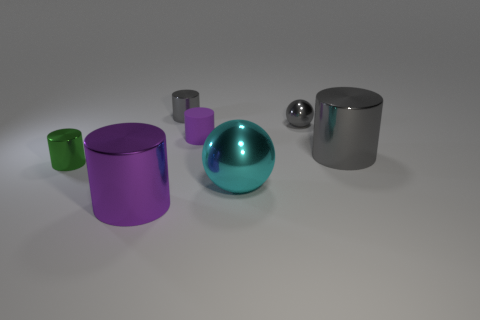Are there any other things that have the same material as the tiny purple thing?
Your answer should be very brief. No. What material is the tiny cylinder that is right of the tiny gray thing that is left of the metallic sphere that is in front of the small purple rubber cylinder made of?
Ensure brevity in your answer.  Rubber. What number of other objects are the same size as the gray ball?
Provide a short and direct response. 3. What size is the object that is the same color as the tiny rubber cylinder?
Keep it short and to the point. Large. Are there more gray metallic objects on the right side of the small metallic ball than big green rubber things?
Your response must be concise. Yes. Is there another object of the same color as the small rubber object?
Ensure brevity in your answer.  Yes. What color is the sphere that is the same size as the purple matte thing?
Provide a succinct answer. Gray. There is a purple cylinder on the right side of the small gray cylinder; how many tiny green metallic things are left of it?
Provide a succinct answer. 1. How many things are purple cylinders in front of the large gray metal cylinder or big gray balls?
Ensure brevity in your answer.  1. How many cyan things have the same material as the small green object?
Keep it short and to the point. 1. 